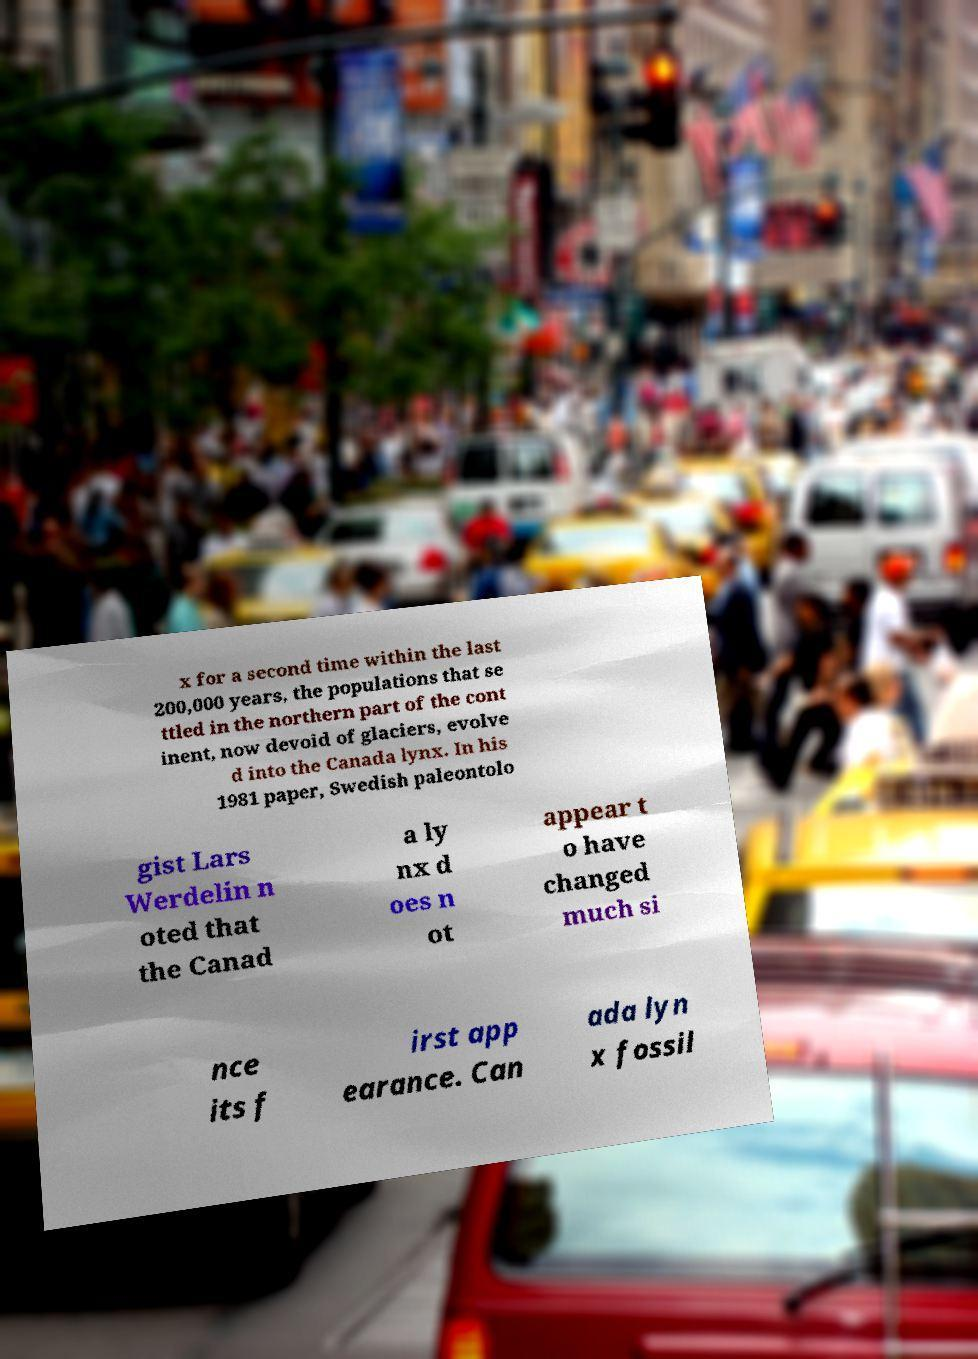Can you accurately transcribe the text from the provided image for me? x for a second time within the last 200,000 years, the populations that se ttled in the northern part of the cont inent, now devoid of glaciers, evolve d into the Canada lynx. In his 1981 paper, Swedish paleontolo gist Lars Werdelin n oted that the Canad a ly nx d oes n ot appear t o have changed much si nce its f irst app earance. Can ada lyn x fossil 